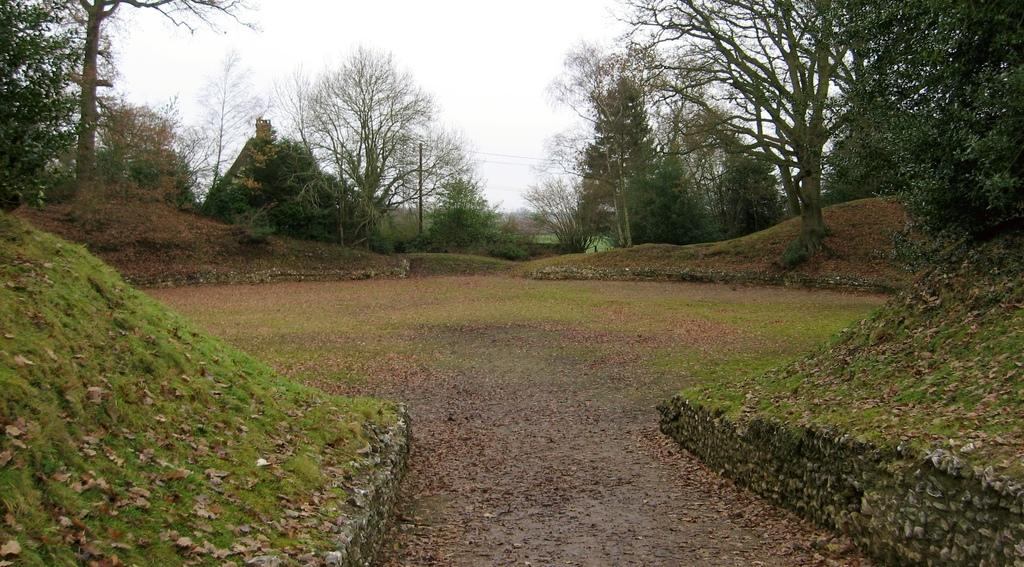What can be seen on the ground in the image? There are dried leaves and grass on the ground in the image. What is the primary feature of the landscape in the image? There is a path in the image. What can be seen in the background of the image? There are trees and the sky visible in the background of the image. How many sisters are walking on the path in the image? There are no people, let alone sisters, present in the image. 